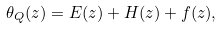Convert formula to latex. <formula><loc_0><loc_0><loc_500><loc_500>\theta _ { Q } ( z ) = E ( z ) + H ( z ) + f ( z ) ,</formula> 